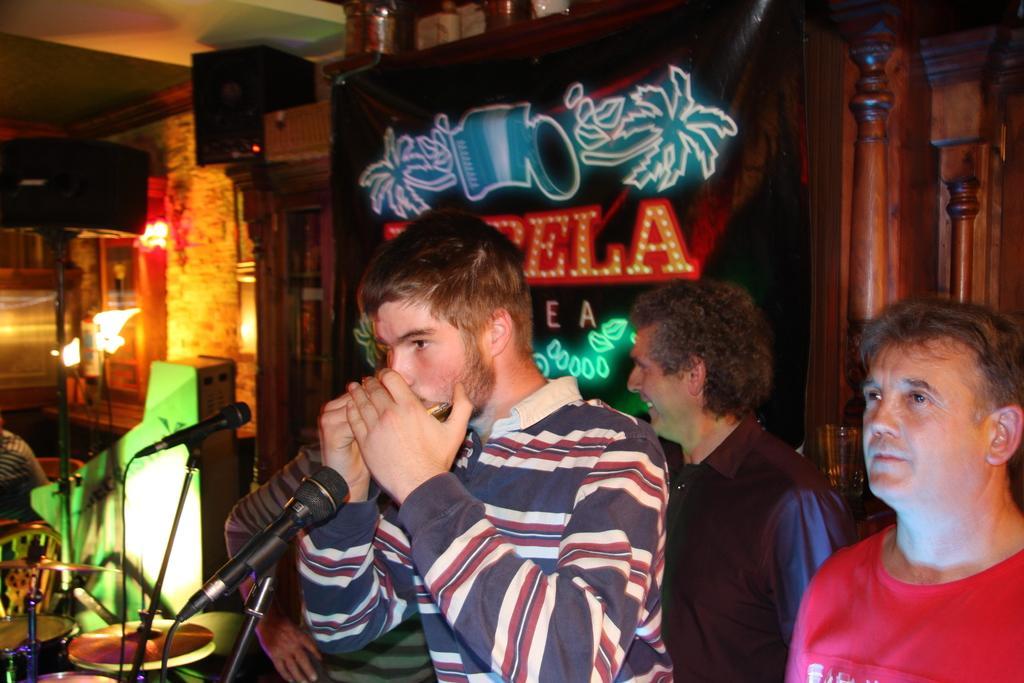Please provide a concise description of this image. In this image, we can see some people standing and there are two microphones, we can see the chairs, in the background, we can see a poster and we can see two wooden pillars. 